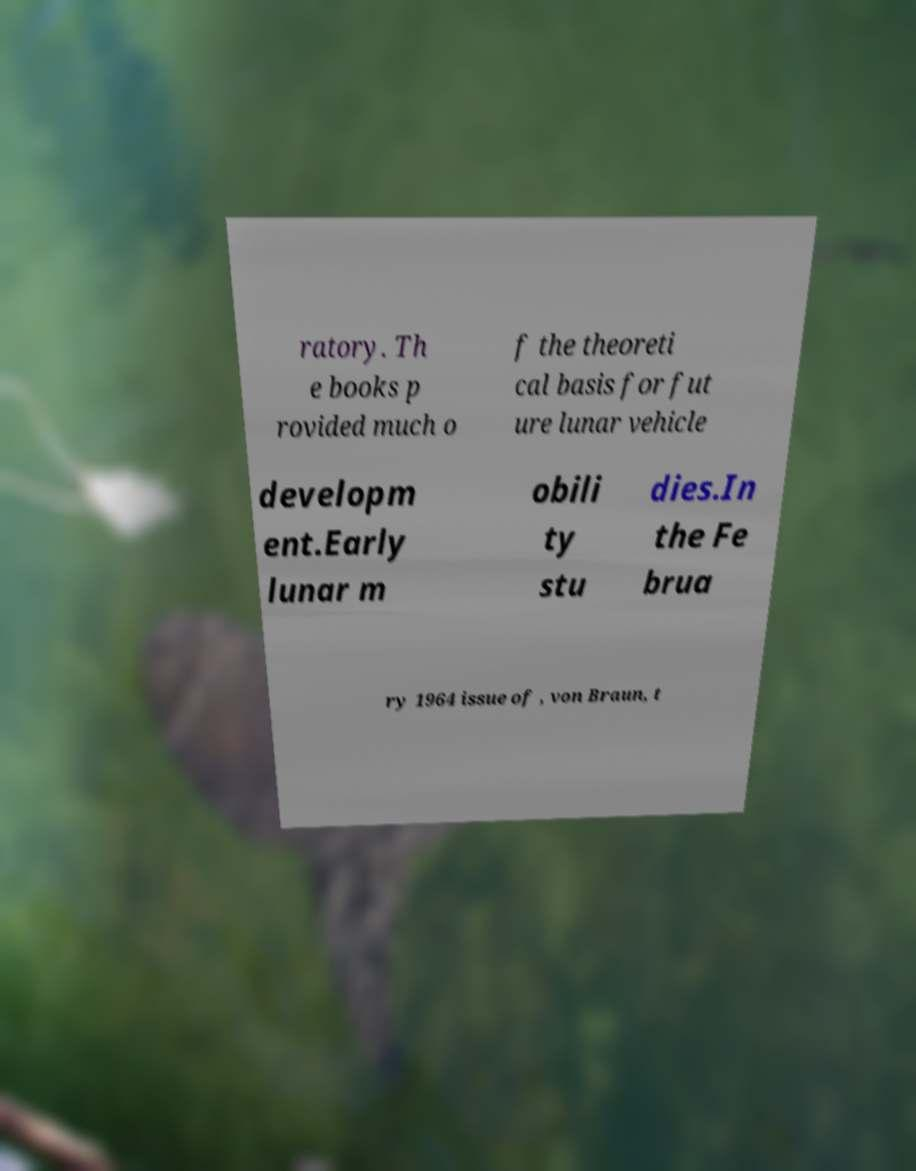Please read and relay the text visible in this image. What does it say? ratory. Th e books p rovided much o f the theoreti cal basis for fut ure lunar vehicle developm ent.Early lunar m obili ty stu dies.In the Fe brua ry 1964 issue of , von Braun, t 